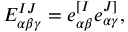<formula> <loc_0><loc_0><loc_500><loc_500>E _ { \alpha \beta \gamma } ^ { I J } = e _ { \alpha \beta } ^ { [ I } e _ { \alpha \gamma } ^ { J ] } ,</formula> 